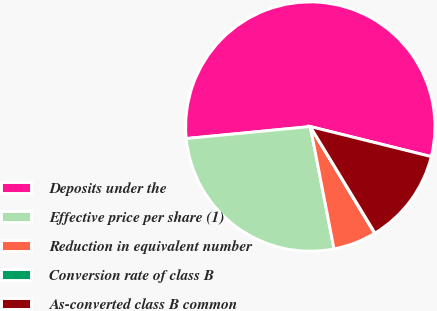Convert chart. <chart><loc_0><loc_0><loc_500><loc_500><pie_chart><fcel>Deposits under the<fcel>Effective price per share (1)<fcel>Reduction in equivalent number<fcel>Conversion rate of class B<fcel>As-converted class B common<nl><fcel>55.41%<fcel>26.51%<fcel>5.59%<fcel>0.05%<fcel>12.44%<nl></chart> 